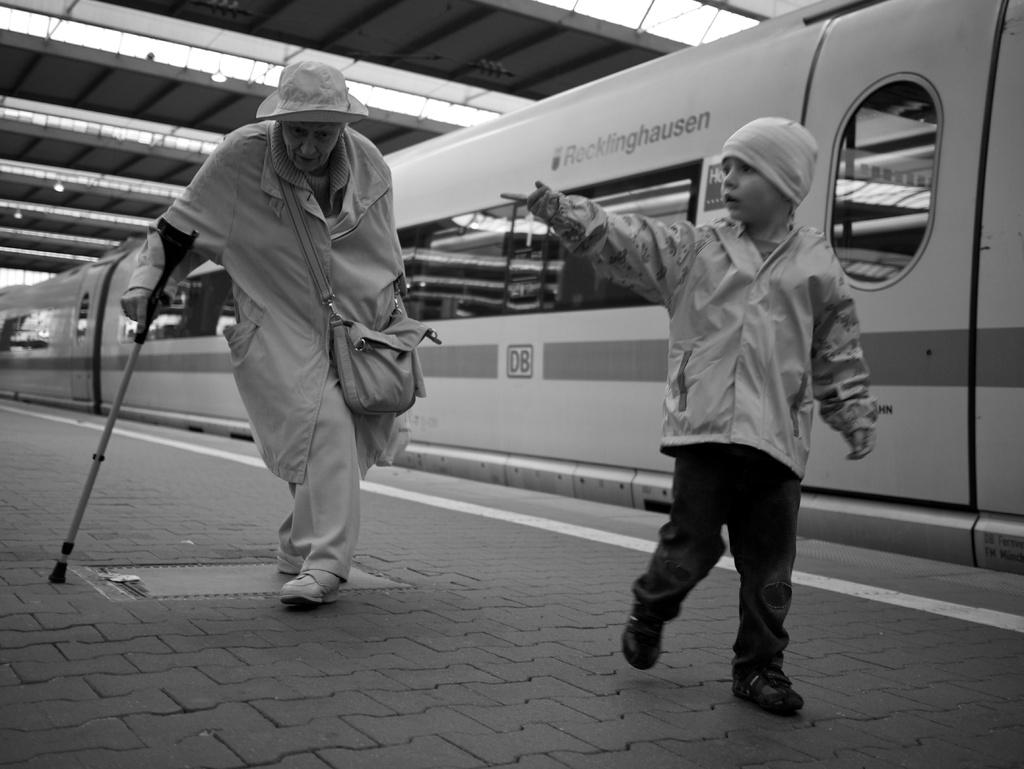What does the train say?
Your answer should be compact. Rocklinghausen. 